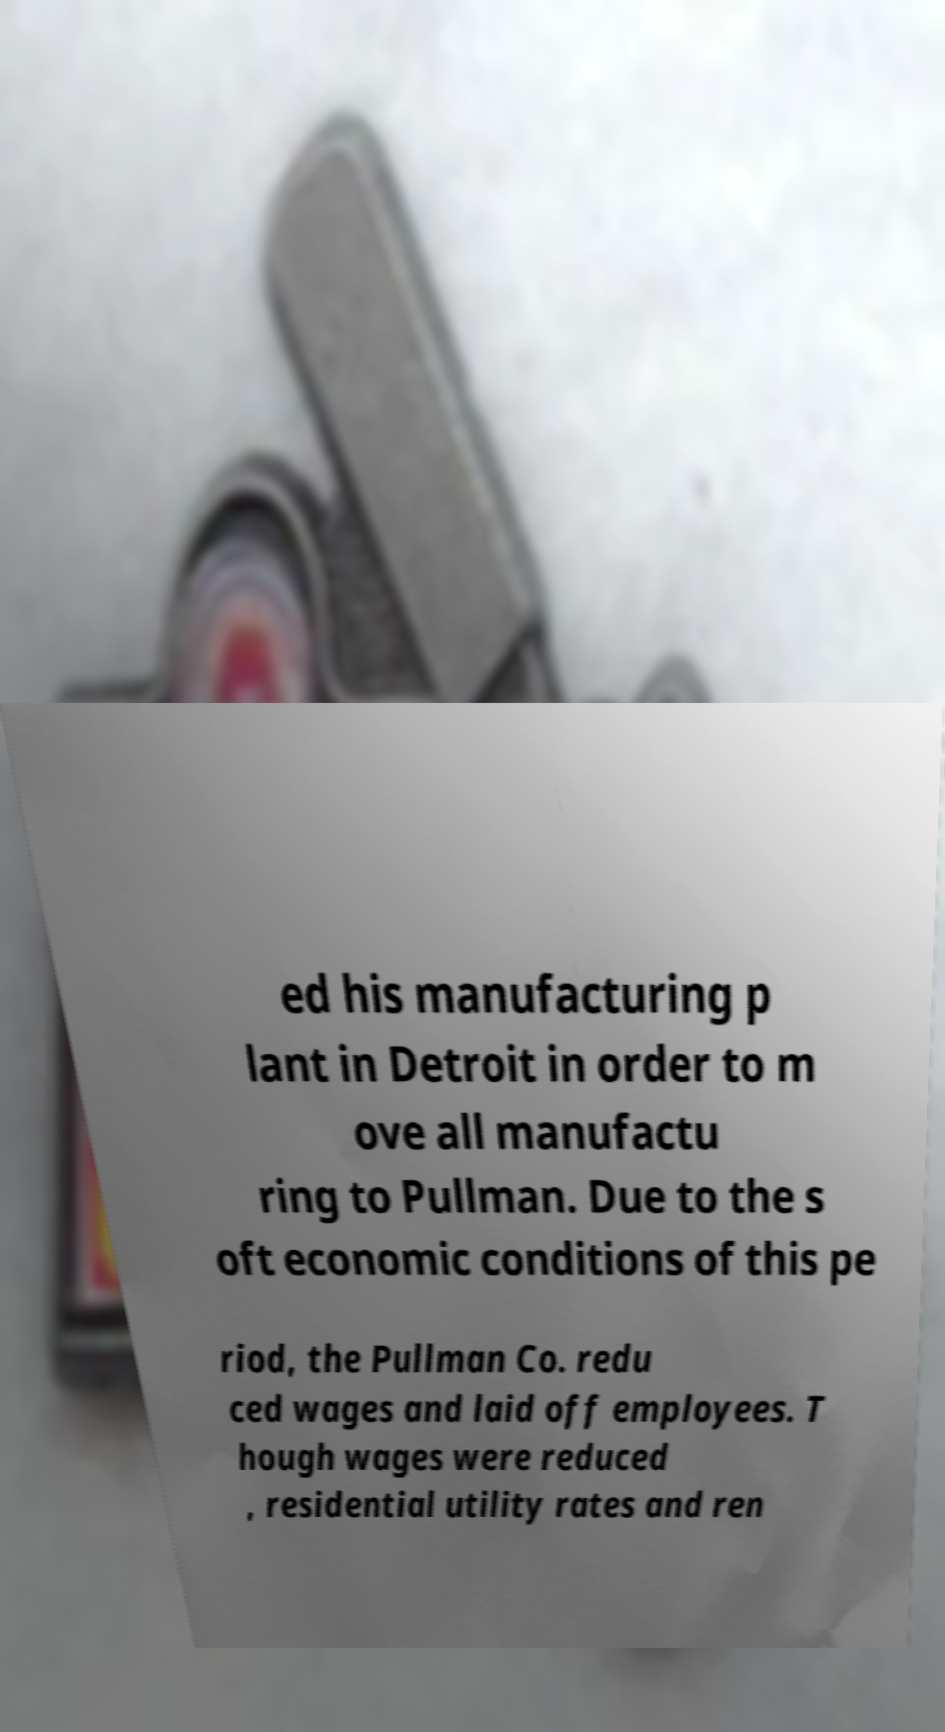Can you read and provide the text displayed in the image?This photo seems to have some interesting text. Can you extract and type it out for me? ed his manufacturing p lant in Detroit in order to m ove all manufactu ring to Pullman. Due to the s oft economic conditions of this pe riod, the Pullman Co. redu ced wages and laid off employees. T hough wages were reduced , residential utility rates and ren 